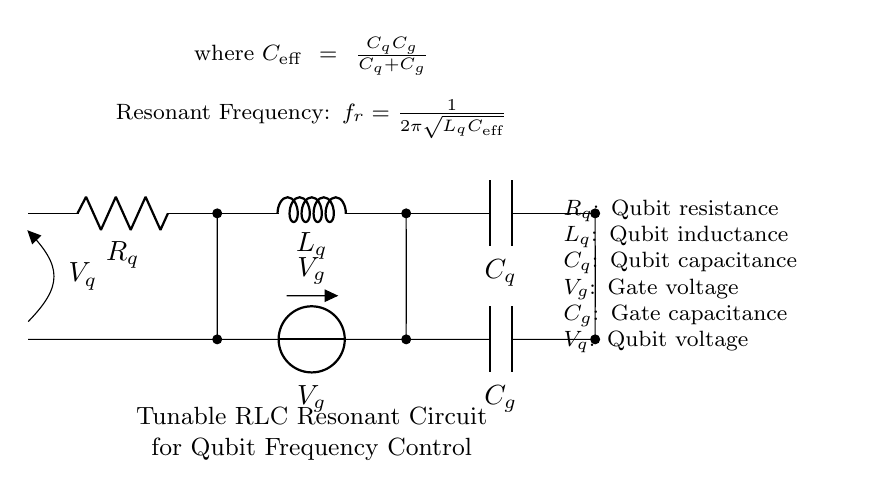What is the resistance value in this circuit? The resistance value is denoted by Rq in the circuit, and it is a character representing the qubit resistance. The symbol does not specify a numerical value in the diagram but indicates its role.
Answer: Rq What components are in the RLC circuit? The components listed in the circuit diagram are a resistor (Rq), an inductor (Lq), and a capacitor (Cq). These components are arranged in series as indicated by the diagram.
Answer: Resistor, Inductor, Capacitor How is the effective capacitance calculated? The effective capacitance, denoted as C_eff, is calculated using the formula C_q * C_g / (C_q + C_g). This formula is derived from the series capacitance rule, which considers how capacitors behave in conjunction.
Answer: C_q * C_g / (C_q + C_g) What is the resonant frequency formula? The resonant frequency is given by the expression f_r = 1 / (2π√(L_q C_eff)). This formula shows how frequency is dependent on inductance and effective capacitance, both of which are critical for tuning qubit frequencies.
Answer: 1 / (2π√(L_q C_eff)) What is the relationship between frequency and component values? The resonant frequency decreases as either the inductance (L_q) increases or the effective capacitance (C_eff) increases. This inverse relationship affects how the circuit is tuned to meet specific frequency requirements for qubit operation.
Answer: Inverse relationship What is the importance of V_g in the circuit? V_g represents the gate voltage applied to the circuit. This voltage is essential as it drives the response of the qubit and influences the tuning of the resonant circuit's frequency.
Answer: Gate voltage 